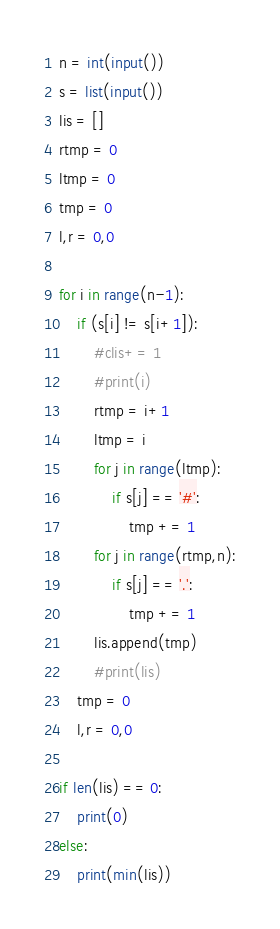<code> <loc_0><loc_0><loc_500><loc_500><_Python_>n = int(input())
s = list(input())
lis = []
rtmp = 0
ltmp = 0
tmp = 0
l,r = 0,0

for i in range(n-1):
    if (s[i] != s[i+1]):
        #clis+= 1
        #print(i)
        rtmp = i+1
        ltmp = i
        for j in range(ltmp):
            if s[j] == '#':
                tmp += 1
        for j in range(rtmp,n):
            if s[j] == '.':
                tmp += 1
        lis.append(tmp)
        #print(lis)
    tmp = 0
    l,r = 0,0

if len(lis) == 0: 
    print(0)
else:
    print(min(lis))
</code> 